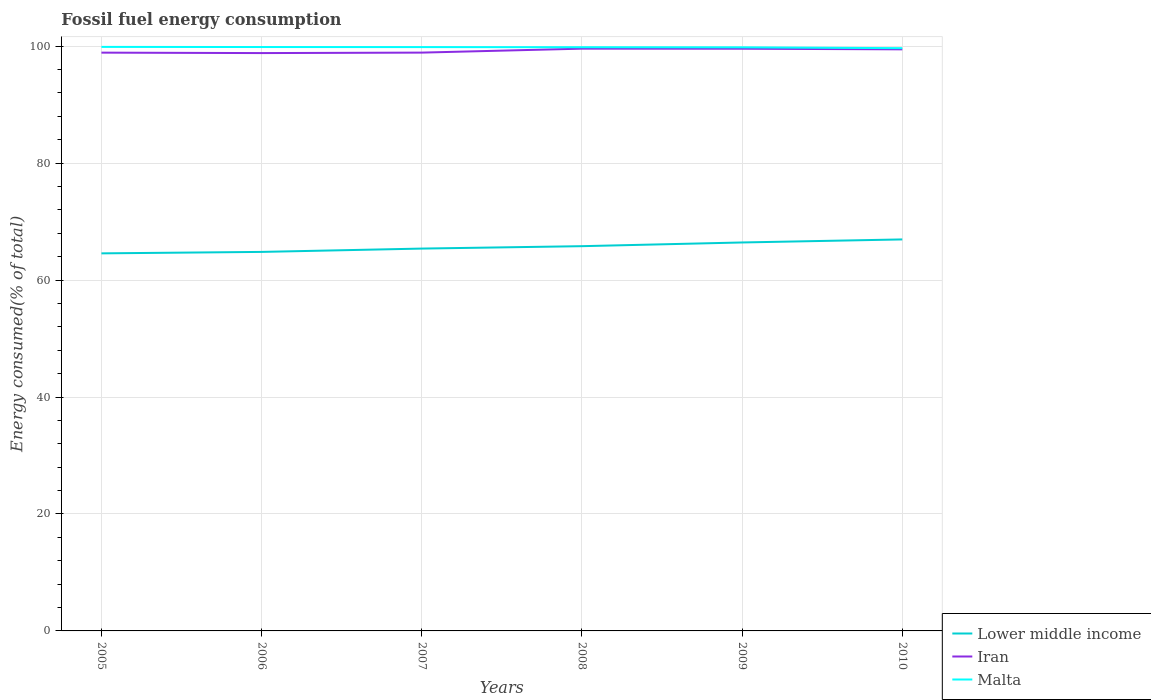Does the line corresponding to Lower middle income intersect with the line corresponding to Iran?
Provide a short and direct response. No. Is the number of lines equal to the number of legend labels?
Provide a succinct answer. Yes. Across all years, what is the maximum percentage of energy consumed in Malta?
Give a very brief answer. 99.65. What is the total percentage of energy consumed in Lower middle income in the graph?
Ensure brevity in your answer.  -1.56. What is the difference between the highest and the second highest percentage of energy consumed in Malta?
Provide a succinct answer. 0.22. Is the percentage of energy consumed in Lower middle income strictly greater than the percentage of energy consumed in Iran over the years?
Your answer should be very brief. Yes. What is the difference between two consecutive major ticks on the Y-axis?
Your answer should be very brief. 20. Are the values on the major ticks of Y-axis written in scientific E-notation?
Provide a short and direct response. No. Where does the legend appear in the graph?
Your response must be concise. Bottom right. How are the legend labels stacked?
Your answer should be compact. Vertical. What is the title of the graph?
Your answer should be compact. Fossil fuel energy consumption. Does "China" appear as one of the legend labels in the graph?
Provide a succinct answer. No. What is the label or title of the Y-axis?
Offer a very short reply. Energy consumed(% of total). What is the Energy consumed(% of total) of Lower middle income in 2005?
Your answer should be very brief. 64.57. What is the Energy consumed(% of total) in Iran in 2005?
Your answer should be very brief. 98.89. What is the Energy consumed(% of total) of Malta in 2005?
Your answer should be compact. 99.87. What is the Energy consumed(% of total) in Lower middle income in 2006?
Offer a very short reply. 64.81. What is the Energy consumed(% of total) of Iran in 2006?
Give a very brief answer. 98.81. What is the Energy consumed(% of total) of Malta in 2006?
Your answer should be very brief. 99.85. What is the Energy consumed(% of total) of Lower middle income in 2007?
Make the answer very short. 65.39. What is the Energy consumed(% of total) in Iran in 2007?
Give a very brief answer. 98.9. What is the Energy consumed(% of total) in Malta in 2007?
Your answer should be compact. 99.84. What is the Energy consumed(% of total) in Lower middle income in 2008?
Your answer should be very brief. 65.79. What is the Energy consumed(% of total) in Iran in 2008?
Your response must be concise. 99.57. What is the Energy consumed(% of total) of Malta in 2008?
Make the answer very short. 99.82. What is the Energy consumed(% of total) in Lower middle income in 2009?
Your response must be concise. 66.43. What is the Energy consumed(% of total) in Iran in 2009?
Offer a very short reply. 99.56. What is the Energy consumed(% of total) of Malta in 2009?
Offer a very short reply. 99.8. What is the Energy consumed(% of total) in Lower middle income in 2010?
Your answer should be compact. 66.95. What is the Energy consumed(% of total) of Iran in 2010?
Make the answer very short. 99.45. What is the Energy consumed(% of total) of Malta in 2010?
Provide a succinct answer. 99.65. Across all years, what is the maximum Energy consumed(% of total) of Lower middle income?
Keep it short and to the point. 66.95. Across all years, what is the maximum Energy consumed(% of total) of Iran?
Provide a succinct answer. 99.57. Across all years, what is the maximum Energy consumed(% of total) in Malta?
Give a very brief answer. 99.87. Across all years, what is the minimum Energy consumed(% of total) of Lower middle income?
Make the answer very short. 64.57. Across all years, what is the minimum Energy consumed(% of total) of Iran?
Ensure brevity in your answer.  98.81. Across all years, what is the minimum Energy consumed(% of total) of Malta?
Your answer should be very brief. 99.65. What is the total Energy consumed(% of total) of Lower middle income in the graph?
Give a very brief answer. 393.94. What is the total Energy consumed(% of total) in Iran in the graph?
Your answer should be compact. 595.19. What is the total Energy consumed(% of total) of Malta in the graph?
Your response must be concise. 598.84. What is the difference between the Energy consumed(% of total) of Lower middle income in 2005 and that in 2006?
Provide a short and direct response. -0.25. What is the difference between the Energy consumed(% of total) in Iran in 2005 and that in 2006?
Your response must be concise. 0.08. What is the difference between the Energy consumed(% of total) in Malta in 2005 and that in 2006?
Offer a terse response. 0.02. What is the difference between the Energy consumed(% of total) in Lower middle income in 2005 and that in 2007?
Your answer should be very brief. -0.82. What is the difference between the Energy consumed(% of total) of Iran in 2005 and that in 2007?
Provide a succinct answer. -0. What is the difference between the Energy consumed(% of total) of Malta in 2005 and that in 2007?
Offer a terse response. 0.03. What is the difference between the Energy consumed(% of total) in Lower middle income in 2005 and that in 2008?
Give a very brief answer. -1.23. What is the difference between the Energy consumed(% of total) of Iran in 2005 and that in 2008?
Give a very brief answer. -0.68. What is the difference between the Energy consumed(% of total) in Malta in 2005 and that in 2008?
Offer a terse response. 0.06. What is the difference between the Energy consumed(% of total) in Lower middle income in 2005 and that in 2009?
Keep it short and to the point. -1.86. What is the difference between the Energy consumed(% of total) in Iran in 2005 and that in 2009?
Provide a short and direct response. -0.67. What is the difference between the Energy consumed(% of total) of Malta in 2005 and that in 2009?
Your response must be concise. 0.07. What is the difference between the Energy consumed(% of total) of Lower middle income in 2005 and that in 2010?
Offer a terse response. -2.38. What is the difference between the Energy consumed(% of total) in Iran in 2005 and that in 2010?
Offer a terse response. -0.56. What is the difference between the Energy consumed(% of total) in Malta in 2005 and that in 2010?
Offer a terse response. 0.22. What is the difference between the Energy consumed(% of total) in Lower middle income in 2006 and that in 2007?
Ensure brevity in your answer.  -0.57. What is the difference between the Energy consumed(% of total) in Iran in 2006 and that in 2007?
Make the answer very short. -0.08. What is the difference between the Energy consumed(% of total) in Malta in 2006 and that in 2007?
Give a very brief answer. 0.01. What is the difference between the Energy consumed(% of total) of Lower middle income in 2006 and that in 2008?
Provide a succinct answer. -0.98. What is the difference between the Energy consumed(% of total) in Iran in 2006 and that in 2008?
Ensure brevity in your answer.  -0.76. What is the difference between the Energy consumed(% of total) of Malta in 2006 and that in 2008?
Provide a succinct answer. 0.03. What is the difference between the Energy consumed(% of total) of Lower middle income in 2006 and that in 2009?
Ensure brevity in your answer.  -1.61. What is the difference between the Energy consumed(% of total) in Iran in 2006 and that in 2009?
Give a very brief answer. -0.75. What is the difference between the Energy consumed(% of total) in Malta in 2006 and that in 2009?
Your answer should be compact. 0.05. What is the difference between the Energy consumed(% of total) of Lower middle income in 2006 and that in 2010?
Ensure brevity in your answer.  -2.14. What is the difference between the Energy consumed(% of total) in Iran in 2006 and that in 2010?
Make the answer very short. -0.64. What is the difference between the Energy consumed(% of total) of Malta in 2006 and that in 2010?
Make the answer very short. 0.2. What is the difference between the Energy consumed(% of total) in Lower middle income in 2007 and that in 2008?
Offer a terse response. -0.41. What is the difference between the Energy consumed(% of total) in Iran in 2007 and that in 2008?
Offer a very short reply. -0.68. What is the difference between the Energy consumed(% of total) of Malta in 2007 and that in 2008?
Offer a terse response. 0.02. What is the difference between the Energy consumed(% of total) in Lower middle income in 2007 and that in 2009?
Your response must be concise. -1.04. What is the difference between the Energy consumed(% of total) in Iran in 2007 and that in 2009?
Make the answer very short. -0.67. What is the difference between the Energy consumed(% of total) of Malta in 2007 and that in 2009?
Ensure brevity in your answer.  0.04. What is the difference between the Energy consumed(% of total) in Lower middle income in 2007 and that in 2010?
Give a very brief answer. -1.56. What is the difference between the Energy consumed(% of total) of Iran in 2007 and that in 2010?
Ensure brevity in your answer.  -0.56. What is the difference between the Energy consumed(% of total) of Malta in 2007 and that in 2010?
Offer a terse response. 0.18. What is the difference between the Energy consumed(% of total) of Lower middle income in 2008 and that in 2009?
Give a very brief answer. -0.63. What is the difference between the Energy consumed(% of total) of Iran in 2008 and that in 2009?
Your response must be concise. 0.01. What is the difference between the Energy consumed(% of total) in Malta in 2008 and that in 2009?
Your answer should be compact. 0.02. What is the difference between the Energy consumed(% of total) in Lower middle income in 2008 and that in 2010?
Provide a succinct answer. -1.16. What is the difference between the Energy consumed(% of total) of Iran in 2008 and that in 2010?
Make the answer very short. 0.12. What is the difference between the Energy consumed(% of total) of Malta in 2008 and that in 2010?
Give a very brief answer. 0.16. What is the difference between the Energy consumed(% of total) of Lower middle income in 2009 and that in 2010?
Provide a short and direct response. -0.52. What is the difference between the Energy consumed(% of total) of Iran in 2009 and that in 2010?
Your answer should be very brief. 0.11. What is the difference between the Energy consumed(% of total) of Malta in 2009 and that in 2010?
Your answer should be compact. 0.15. What is the difference between the Energy consumed(% of total) in Lower middle income in 2005 and the Energy consumed(% of total) in Iran in 2006?
Your answer should be compact. -34.25. What is the difference between the Energy consumed(% of total) of Lower middle income in 2005 and the Energy consumed(% of total) of Malta in 2006?
Your response must be concise. -35.28. What is the difference between the Energy consumed(% of total) of Iran in 2005 and the Energy consumed(% of total) of Malta in 2006?
Your answer should be compact. -0.96. What is the difference between the Energy consumed(% of total) of Lower middle income in 2005 and the Energy consumed(% of total) of Iran in 2007?
Keep it short and to the point. -34.33. What is the difference between the Energy consumed(% of total) of Lower middle income in 2005 and the Energy consumed(% of total) of Malta in 2007?
Make the answer very short. -35.27. What is the difference between the Energy consumed(% of total) of Iran in 2005 and the Energy consumed(% of total) of Malta in 2007?
Give a very brief answer. -0.95. What is the difference between the Energy consumed(% of total) of Lower middle income in 2005 and the Energy consumed(% of total) of Iran in 2008?
Offer a very short reply. -35.01. What is the difference between the Energy consumed(% of total) in Lower middle income in 2005 and the Energy consumed(% of total) in Malta in 2008?
Provide a short and direct response. -35.25. What is the difference between the Energy consumed(% of total) in Iran in 2005 and the Energy consumed(% of total) in Malta in 2008?
Offer a terse response. -0.93. What is the difference between the Energy consumed(% of total) of Lower middle income in 2005 and the Energy consumed(% of total) of Iran in 2009?
Your answer should be very brief. -35. What is the difference between the Energy consumed(% of total) of Lower middle income in 2005 and the Energy consumed(% of total) of Malta in 2009?
Offer a very short reply. -35.23. What is the difference between the Energy consumed(% of total) of Iran in 2005 and the Energy consumed(% of total) of Malta in 2009?
Ensure brevity in your answer.  -0.91. What is the difference between the Energy consumed(% of total) in Lower middle income in 2005 and the Energy consumed(% of total) in Iran in 2010?
Keep it short and to the point. -34.89. What is the difference between the Energy consumed(% of total) of Lower middle income in 2005 and the Energy consumed(% of total) of Malta in 2010?
Your answer should be very brief. -35.09. What is the difference between the Energy consumed(% of total) of Iran in 2005 and the Energy consumed(% of total) of Malta in 2010?
Keep it short and to the point. -0.76. What is the difference between the Energy consumed(% of total) of Lower middle income in 2006 and the Energy consumed(% of total) of Iran in 2007?
Keep it short and to the point. -34.08. What is the difference between the Energy consumed(% of total) of Lower middle income in 2006 and the Energy consumed(% of total) of Malta in 2007?
Offer a very short reply. -35.03. What is the difference between the Energy consumed(% of total) in Iran in 2006 and the Energy consumed(% of total) in Malta in 2007?
Give a very brief answer. -1.02. What is the difference between the Energy consumed(% of total) in Lower middle income in 2006 and the Energy consumed(% of total) in Iran in 2008?
Your answer should be compact. -34.76. What is the difference between the Energy consumed(% of total) of Lower middle income in 2006 and the Energy consumed(% of total) of Malta in 2008?
Provide a short and direct response. -35. What is the difference between the Energy consumed(% of total) of Iran in 2006 and the Energy consumed(% of total) of Malta in 2008?
Make the answer very short. -1. What is the difference between the Energy consumed(% of total) in Lower middle income in 2006 and the Energy consumed(% of total) in Iran in 2009?
Ensure brevity in your answer.  -34.75. What is the difference between the Energy consumed(% of total) of Lower middle income in 2006 and the Energy consumed(% of total) of Malta in 2009?
Your response must be concise. -34.99. What is the difference between the Energy consumed(% of total) in Iran in 2006 and the Energy consumed(% of total) in Malta in 2009?
Provide a succinct answer. -0.99. What is the difference between the Energy consumed(% of total) in Lower middle income in 2006 and the Energy consumed(% of total) in Iran in 2010?
Ensure brevity in your answer.  -34.64. What is the difference between the Energy consumed(% of total) of Lower middle income in 2006 and the Energy consumed(% of total) of Malta in 2010?
Your answer should be compact. -34.84. What is the difference between the Energy consumed(% of total) in Iran in 2006 and the Energy consumed(% of total) in Malta in 2010?
Your response must be concise. -0.84. What is the difference between the Energy consumed(% of total) in Lower middle income in 2007 and the Energy consumed(% of total) in Iran in 2008?
Give a very brief answer. -34.19. What is the difference between the Energy consumed(% of total) in Lower middle income in 2007 and the Energy consumed(% of total) in Malta in 2008?
Your answer should be very brief. -34.43. What is the difference between the Energy consumed(% of total) in Iran in 2007 and the Energy consumed(% of total) in Malta in 2008?
Offer a very short reply. -0.92. What is the difference between the Energy consumed(% of total) in Lower middle income in 2007 and the Energy consumed(% of total) in Iran in 2009?
Keep it short and to the point. -34.18. What is the difference between the Energy consumed(% of total) of Lower middle income in 2007 and the Energy consumed(% of total) of Malta in 2009?
Provide a succinct answer. -34.42. What is the difference between the Energy consumed(% of total) in Iran in 2007 and the Energy consumed(% of total) in Malta in 2009?
Offer a very short reply. -0.91. What is the difference between the Energy consumed(% of total) in Lower middle income in 2007 and the Energy consumed(% of total) in Iran in 2010?
Make the answer very short. -34.07. What is the difference between the Energy consumed(% of total) of Lower middle income in 2007 and the Energy consumed(% of total) of Malta in 2010?
Provide a succinct answer. -34.27. What is the difference between the Energy consumed(% of total) of Iran in 2007 and the Energy consumed(% of total) of Malta in 2010?
Give a very brief answer. -0.76. What is the difference between the Energy consumed(% of total) of Lower middle income in 2008 and the Energy consumed(% of total) of Iran in 2009?
Keep it short and to the point. -33.77. What is the difference between the Energy consumed(% of total) in Lower middle income in 2008 and the Energy consumed(% of total) in Malta in 2009?
Provide a short and direct response. -34.01. What is the difference between the Energy consumed(% of total) in Iran in 2008 and the Energy consumed(% of total) in Malta in 2009?
Ensure brevity in your answer.  -0.23. What is the difference between the Energy consumed(% of total) in Lower middle income in 2008 and the Energy consumed(% of total) in Iran in 2010?
Offer a terse response. -33.66. What is the difference between the Energy consumed(% of total) of Lower middle income in 2008 and the Energy consumed(% of total) of Malta in 2010?
Keep it short and to the point. -33.86. What is the difference between the Energy consumed(% of total) of Iran in 2008 and the Energy consumed(% of total) of Malta in 2010?
Your answer should be compact. -0.08. What is the difference between the Energy consumed(% of total) in Lower middle income in 2009 and the Energy consumed(% of total) in Iran in 2010?
Your answer should be compact. -33.03. What is the difference between the Energy consumed(% of total) of Lower middle income in 2009 and the Energy consumed(% of total) of Malta in 2010?
Make the answer very short. -33.23. What is the difference between the Energy consumed(% of total) in Iran in 2009 and the Energy consumed(% of total) in Malta in 2010?
Provide a succinct answer. -0.09. What is the average Energy consumed(% of total) of Lower middle income per year?
Your response must be concise. 65.66. What is the average Energy consumed(% of total) of Iran per year?
Your answer should be very brief. 99.2. What is the average Energy consumed(% of total) in Malta per year?
Keep it short and to the point. 99.81. In the year 2005, what is the difference between the Energy consumed(% of total) in Lower middle income and Energy consumed(% of total) in Iran?
Your answer should be very brief. -34.33. In the year 2005, what is the difference between the Energy consumed(% of total) of Lower middle income and Energy consumed(% of total) of Malta?
Offer a very short reply. -35.31. In the year 2005, what is the difference between the Energy consumed(% of total) of Iran and Energy consumed(% of total) of Malta?
Offer a terse response. -0.98. In the year 2006, what is the difference between the Energy consumed(% of total) of Lower middle income and Energy consumed(% of total) of Iran?
Keep it short and to the point. -34. In the year 2006, what is the difference between the Energy consumed(% of total) in Lower middle income and Energy consumed(% of total) in Malta?
Your answer should be very brief. -35.04. In the year 2006, what is the difference between the Energy consumed(% of total) in Iran and Energy consumed(% of total) in Malta?
Give a very brief answer. -1.04. In the year 2007, what is the difference between the Energy consumed(% of total) of Lower middle income and Energy consumed(% of total) of Iran?
Offer a very short reply. -33.51. In the year 2007, what is the difference between the Energy consumed(% of total) of Lower middle income and Energy consumed(% of total) of Malta?
Offer a very short reply. -34.45. In the year 2007, what is the difference between the Energy consumed(% of total) of Iran and Energy consumed(% of total) of Malta?
Offer a terse response. -0.94. In the year 2008, what is the difference between the Energy consumed(% of total) of Lower middle income and Energy consumed(% of total) of Iran?
Provide a short and direct response. -33.78. In the year 2008, what is the difference between the Energy consumed(% of total) of Lower middle income and Energy consumed(% of total) of Malta?
Provide a succinct answer. -34.02. In the year 2008, what is the difference between the Energy consumed(% of total) of Iran and Energy consumed(% of total) of Malta?
Offer a very short reply. -0.25. In the year 2009, what is the difference between the Energy consumed(% of total) of Lower middle income and Energy consumed(% of total) of Iran?
Offer a very short reply. -33.13. In the year 2009, what is the difference between the Energy consumed(% of total) in Lower middle income and Energy consumed(% of total) in Malta?
Offer a very short reply. -33.37. In the year 2009, what is the difference between the Energy consumed(% of total) of Iran and Energy consumed(% of total) of Malta?
Offer a terse response. -0.24. In the year 2010, what is the difference between the Energy consumed(% of total) of Lower middle income and Energy consumed(% of total) of Iran?
Give a very brief answer. -32.5. In the year 2010, what is the difference between the Energy consumed(% of total) of Lower middle income and Energy consumed(% of total) of Malta?
Your response must be concise. -32.71. In the year 2010, what is the difference between the Energy consumed(% of total) of Iran and Energy consumed(% of total) of Malta?
Ensure brevity in your answer.  -0.2. What is the ratio of the Energy consumed(% of total) of Iran in 2005 to that in 2006?
Offer a very short reply. 1. What is the ratio of the Energy consumed(% of total) in Lower middle income in 2005 to that in 2007?
Keep it short and to the point. 0.99. What is the ratio of the Energy consumed(% of total) in Lower middle income in 2005 to that in 2008?
Offer a very short reply. 0.98. What is the ratio of the Energy consumed(% of total) in Malta in 2005 to that in 2008?
Give a very brief answer. 1. What is the ratio of the Energy consumed(% of total) in Malta in 2005 to that in 2009?
Your answer should be compact. 1. What is the ratio of the Energy consumed(% of total) in Lower middle income in 2005 to that in 2010?
Your answer should be very brief. 0.96. What is the ratio of the Energy consumed(% of total) in Lower middle income in 2006 to that in 2007?
Offer a terse response. 0.99. What is the ratio of the Energy consumed(% of total) of Iran in 2006 to that in 2007?
Give a very brief answer. 1. What is the ratio of the Energy consumed(% of total) of Malta in 2006 to that in 2007?
Your answer should be very brief. 1. What is the ratio of the Energy consumed(% of total) of Lower middle income in 2006 to that in 2008?
Keep it short and to the point. 0.99. What is the ratio of the Energy consumed(% of total) of Lower middle income in 2006 to that in 2009?
Your answer should be very brief. 0.98. What is the ratio of the Energy consumed(% of total) in Malta in 2006 to that in 2009?
Provide a succinct answer. 1. What is the ratio of the Energy consumed(% of total) of Lower middle income in 2006 to that in 2010?
Your answer should be compact. 0.97. What is the ratio of the Energy consumed(% of total) in Malta in 2006 to that in 2010?
Ensure brevity in your answer.  1. What is the ratio of the Energy consumed(% of total) of Lower middle income in 2007 to that in 2008?
Offer a terse response. 0.99. What is the ratio of the Energy consumed(% of total) of Iran in 2007 to that in 2008?
Provide a succinct answer. 0.99. What is the ratio of the Energy consumed(% of total) in Malta in 2007 to that in 2008?
Offer a very short reply. 1. What is the ratio of the Energy consumed(% of total) in Lower middle income in 2007 to that in 2009?
Provide a succinct answer. 0.98. What is the ratio of the Energy consumed(% of total) of Lower middle income in 2007 to that in 2010?
Your response must be concise. 0.98. What is the ratio of the Energy consumed(% of total) in Malta in 2007 to that in 2010?
Your response must be concise. 1. What is the ratio of the Energy consumed(% of total) in Lower middle income in 2008 to that in 2009?
Offer a terse response. 0.99. What is the ratio of the Energy consumed(% of total) of Lower middle income in 2008 to that in 2010?
Give a very brief answer. 0.98. What is the ratio of the Energy consumed(% of total) in Malta in 2008 to that in 2010?
Offer a very short reply. 1. What is the ratio of the Energy consumed(% of total) in Lower middle income in 2009 to that in 2010?
Ensure brevity in your answer.  0.99. What is the ratio of the Energy consumed(% of total) of Malta in 2009 to that in 2010?
Your answer should be compact. 1. What is the difference between the highest and the second highest Energy consumed(% of total) in Lower middle income?
Ensure brevity in your answer.  0.52. What is the difference between the highest and the second highest Energy consumed(% of total) of Iran?
Make the answer very short. 0.01. What is the difference between the highest and the second highest Energy consumed(% of total) of Malta?
Your answer should be compact. 0.02. What is the difference between the highest and the lowest Energy consumed(% of total) of Lower middle income?
Keep it short and to the point. 2.38. What is the difference between the highest and the lowest Energy consumed(% of total) in Iran?
Provide a short and direct response. 0.76. What is the difference between the highest and the lowest Energy consumed(% of total) of Malta?
Your answer should be very brief. 0.22. 